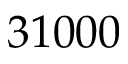Convert formula to latex. <formula><loc_0><loc_0><loc_500><loc_500>3 1 0 0 0</formula> 